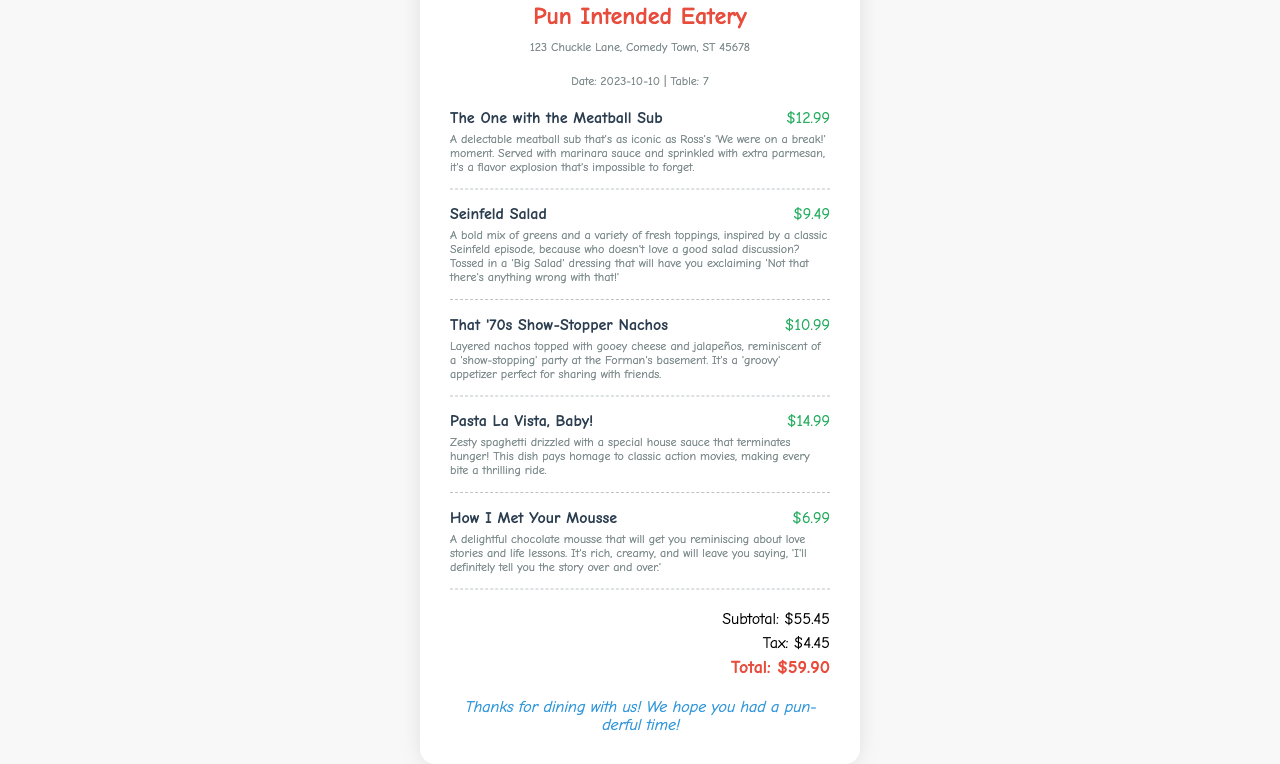What is the name of the restaurant? The restaurant is called "Pun Intended Eatery," as mentioned at the top of the receipt.
Answer: Pun Intended Eatery What is the date of the visit? The date listed on the receipt is "2023-10-10."
Answer: 2023-10-10 What is the subtotal amount? The subtotal is clearly indicated as "$55.45" on the receipt.
Answer: $55.45 How much was the Seinfeld Salad? The price of the Seinfeld Salad is shown as "$9.49" next to its name.
Answer: $9.49 What is the name of the dessert? The dessert listed is called "How I Met Your Mousse," according to the menu items.
Answer: How I Met Your Mousse What is the total amount due? The grand total at the bottom of the receipt indicates the total is "$59.90."
Answer: $59.90 Which menu item costs the most? "Pasta La Vista, Baby!" is the most expensive item priced at "$14.99."
Answer: Pasta La Vista, Baby! What clever theme do the menu items follow? The dishes feature names inspired by popular sitcoms, making for a pun-derful dining experience.
Answer: Sitcoms What is the tax amount listed on the receipt? The tax is displayed as "$4.45" in the totals section.
Answer: $4.45 